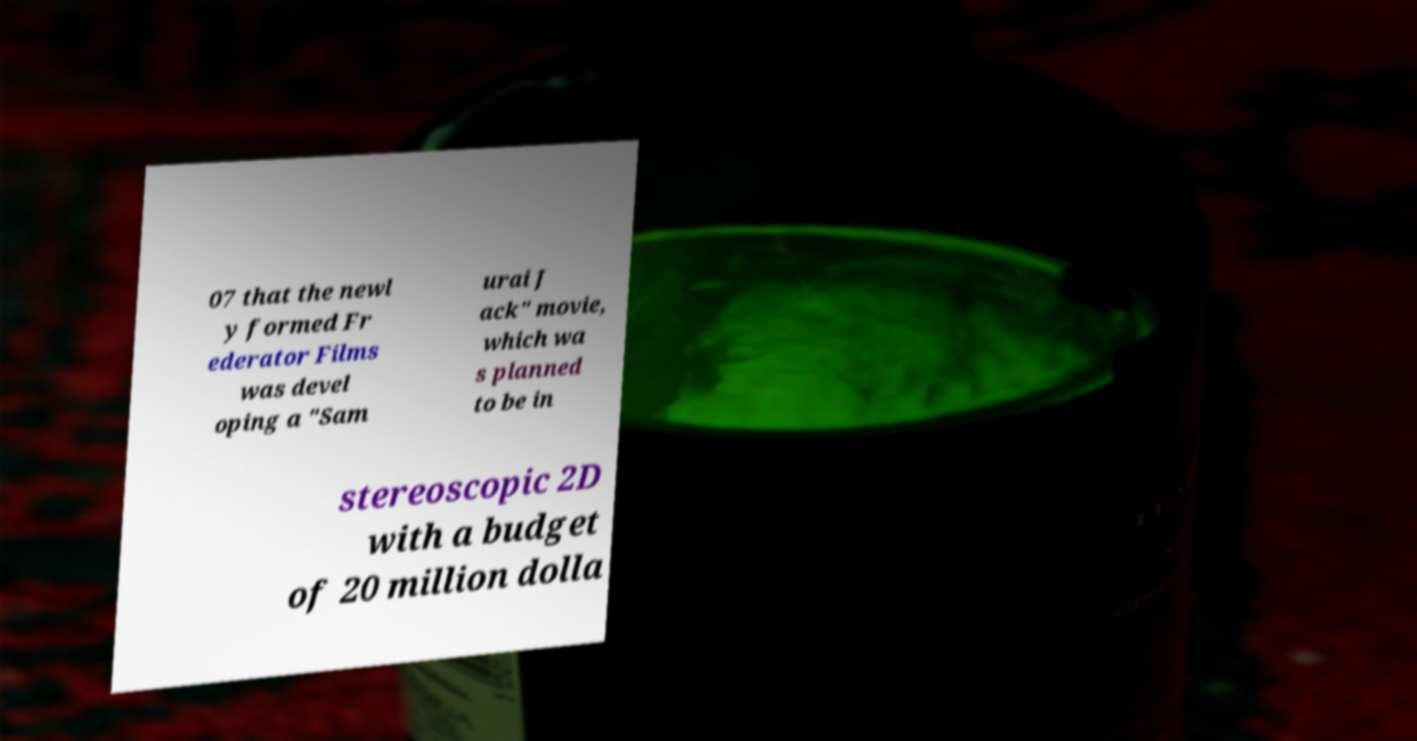Please read and relay the text visible in this image. What does it say? 07 that the newl y formed Fr ederator Films was devel oping a "Sam urai J ack" movie, which wa s planned to be in stereoscopic 2D with a budget of 20 million dolla 